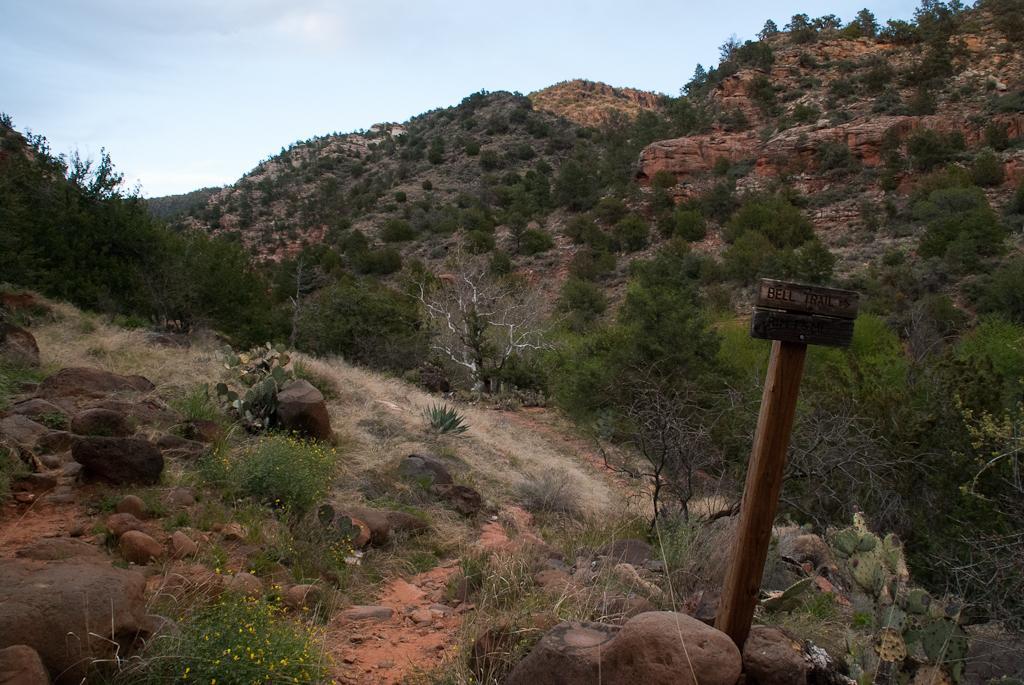Could you give a brief overview of what you see in this image? In this image I can see the stones. On the right side I can see a board with some text written on it. In the background, I can see the hills covered with the trees. At the top I can see the clouds in the sky. 